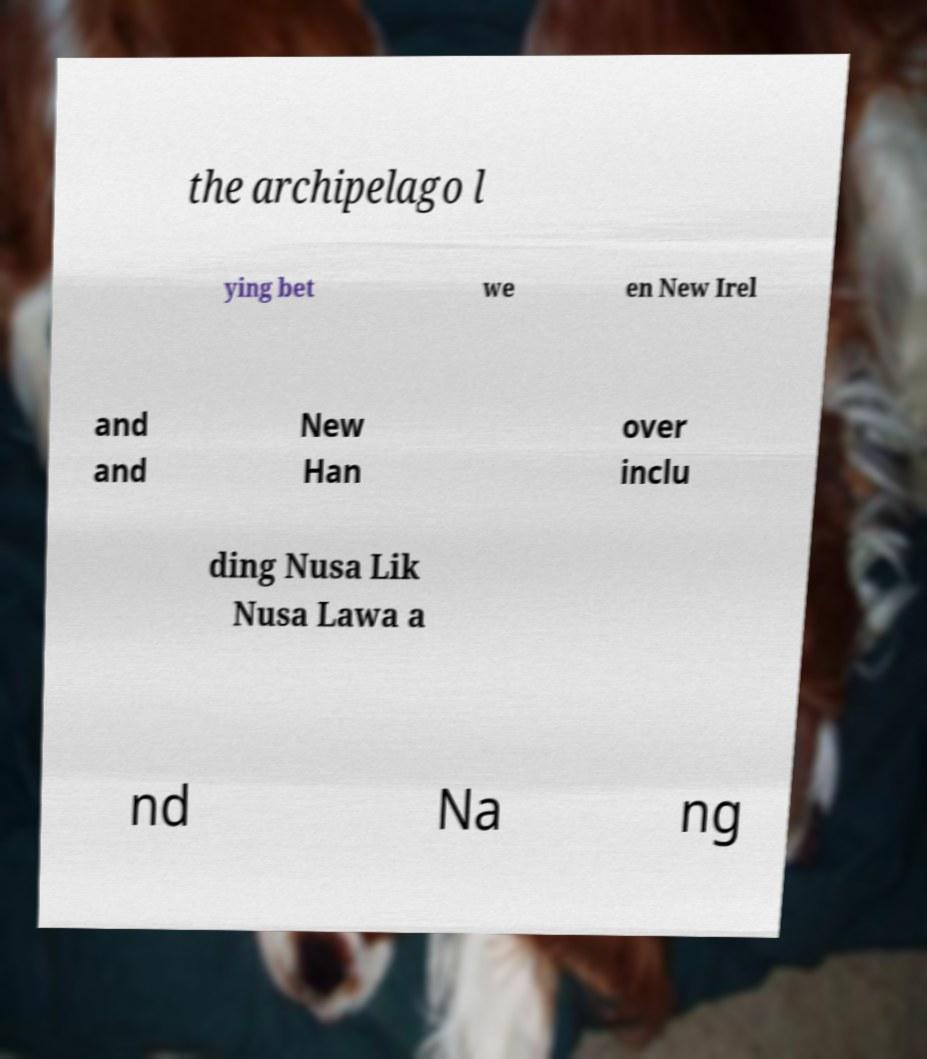Please identify and transcribe the text found in this image. the archipelago l ying bet we en New Irel and and New Han over inclu ding Nusa Lik Nusa Lawa a nd Na ng 